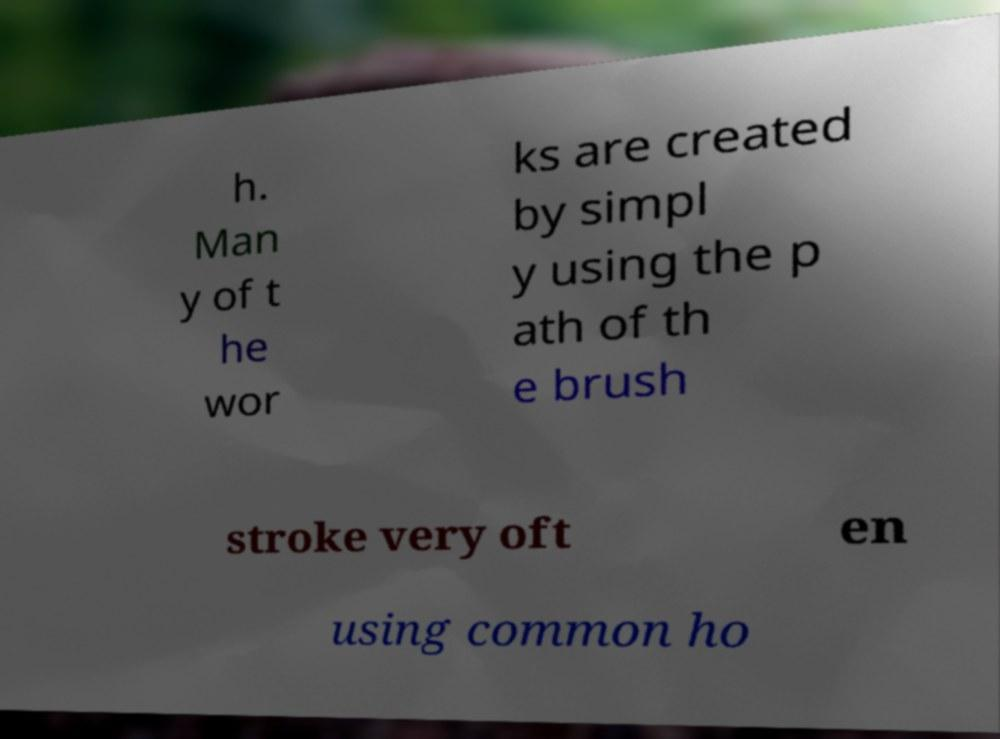There's text embedded in this image that I need extracted. Can you transcribe it verbatim? h. Man y of t he wor ks are created by simpl y using the p ath of th e brush stroke very oft en using common ho 